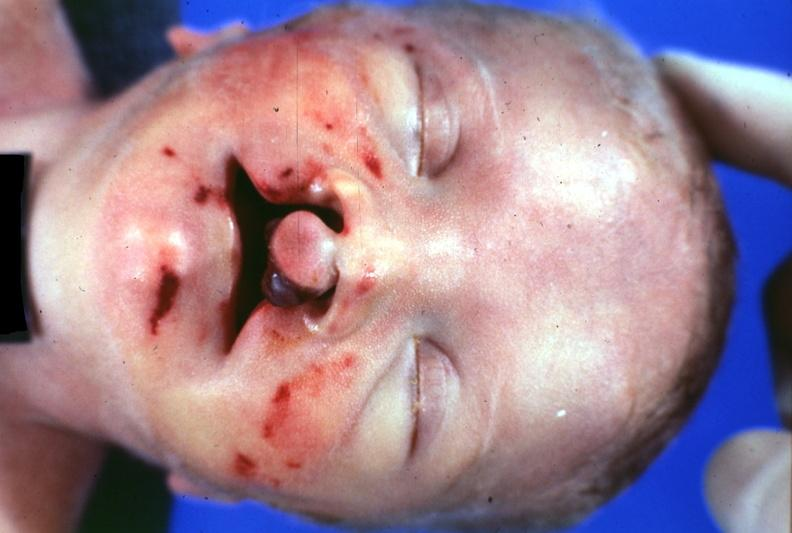s bilateral cleft palate present?
Answer the question using a single word or phrase. Yes 